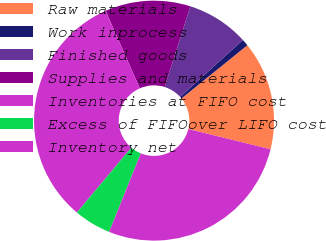Convert chart to OTSL. <chart><loc_0><loc_0><loc_500><loc_500><pie_chart><fcel>Raw materials<fcel>Work inprocess<fcel>Finished goods<fcel>Supplies and materials<fcel>Inventories at FIFO cost<fcel>Excess of FIFOover LIFO cost<fcel>Inventory net<nl><fcel>14.65%<fcel>0.92%<fcel>8.37%<fcel>11.51%<fcel>32.28%<fcel>5.01%<fcel>27.27%<nl></chart> 